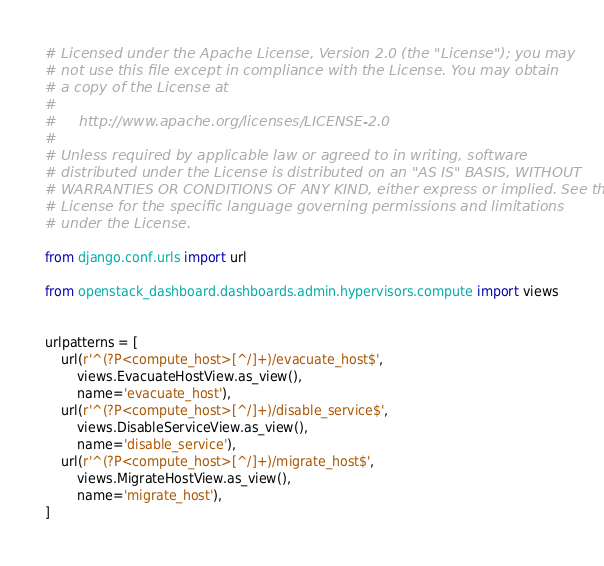<code> <loc_0><loc_0><loc_500><loc_500><_Python_># Licensed under the Apache License, Version 2.0 (the "License"); you may
# not use this file except in compliance with the License. You may obtain
# a copy of the License at
#
#     http://www.apache.org/licenses/LICENSE-2.0
#
# Unless required by applicable law or agreed to in writing, software
# distributed under the License is distributed on an "AS IS" BASIS, WITHOUT
# WARRANTIES OR CONDITIONS OF ANY KIND, either express or implied. See the
# License for the specific language governing permissions and limitations
# under the License.

from django.conf.urls import url

from openstack_dashboard.dashboards.admin.hypervisors.compute import views


urlpatterns = [
    url(r'^(?P<compute_host>[^/]+)/evacuate_host$',
        views.EvacuateHostView.as_view(),
        name='evacuate_host'),
    url(r'^(?P<compute_host>[^/]+)/disable_service$',
        views.DisableServiceView.as_view(),
        name='disable_service'),
    url(r'^(?P<compute_host>[^/]+)/migrate_host$',
        views.MigrateHostView.as_view(),
        name='migrate_host'),
]
</code> 